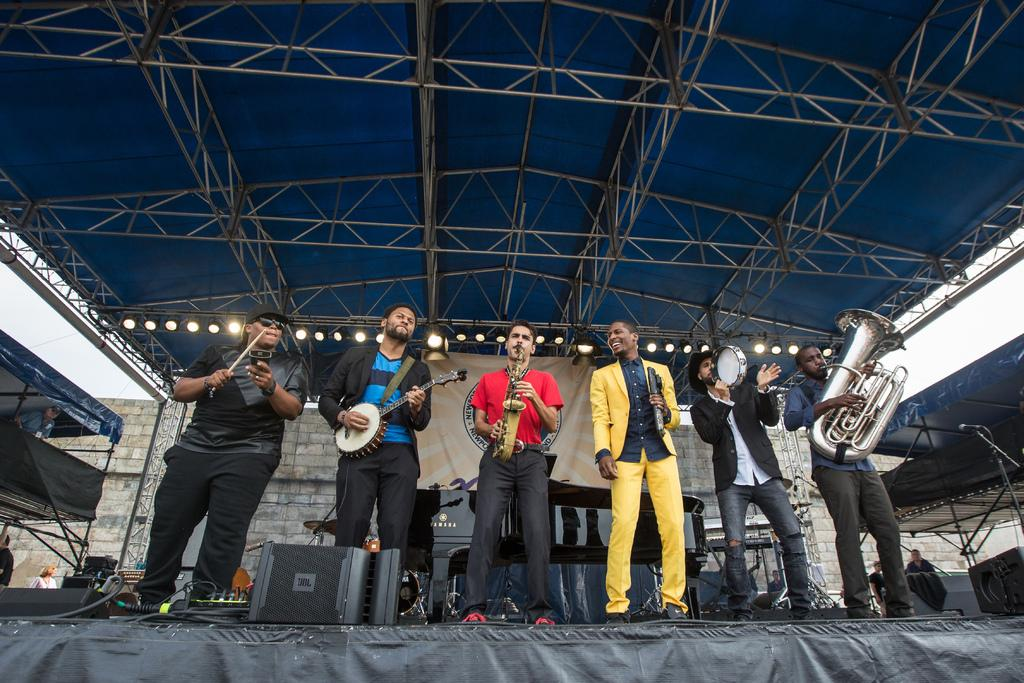How many people are performing on the stage in the image? There are six men on the stage in the image. What are the men doing on the stage? The men are performing by playing musical instruments. What can be seen in the background of the image? There is a wall, people, musical instruments, and a banner in the background of the image. Can you tell me how many horses are visible in the image? There are no horses present in the image. What type of tongue is being used by the musicians in the image? The musicians are not using any tongues in the image; they are playing musical instruments. 